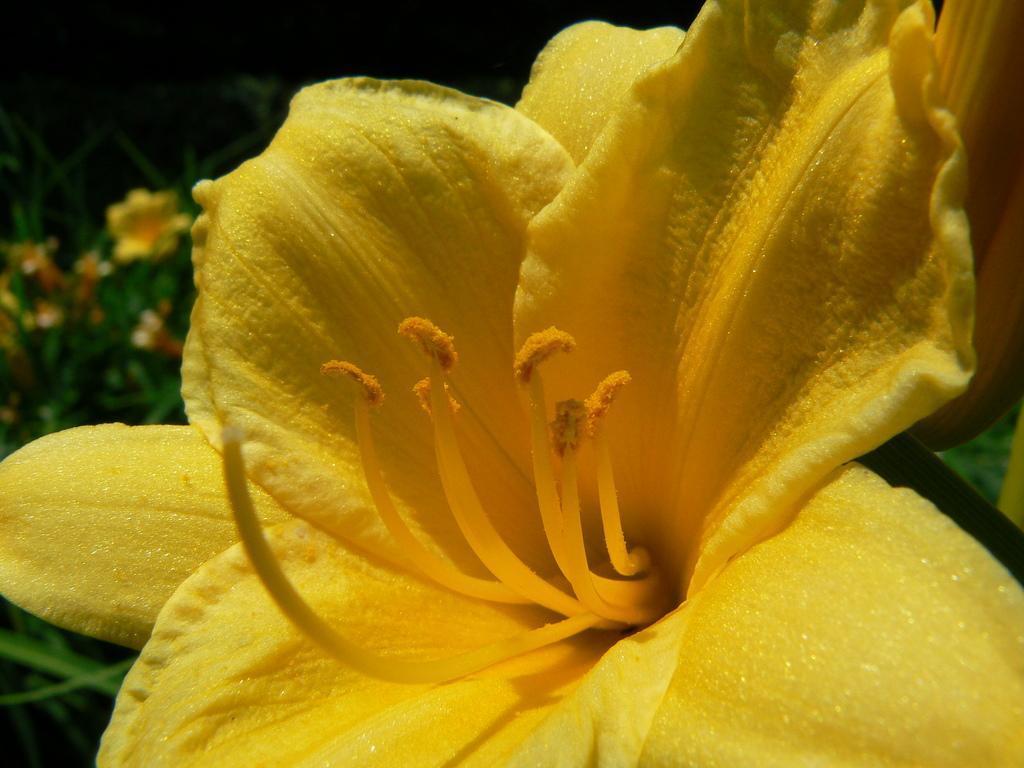In one or two sentences, can you explain what this image depicts? In this picture I can see a yellow color flower, and in the background there are plants with yellow flowers. 